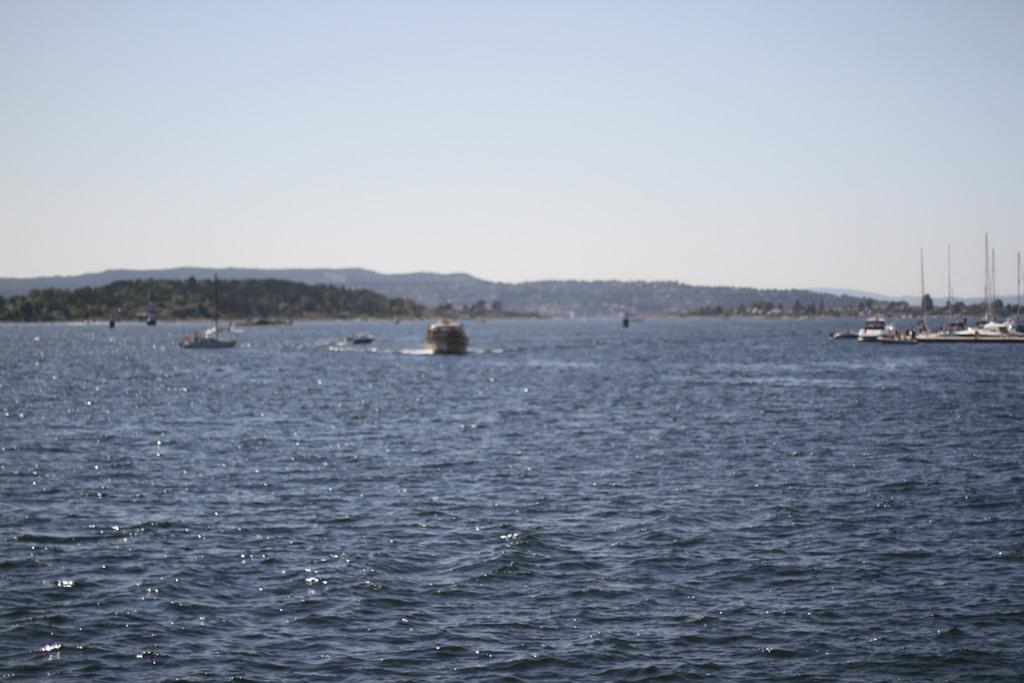Can you describe this image briefly? In this picture I can see boats on the water, there are trees, hills, and in the background there is sky. 